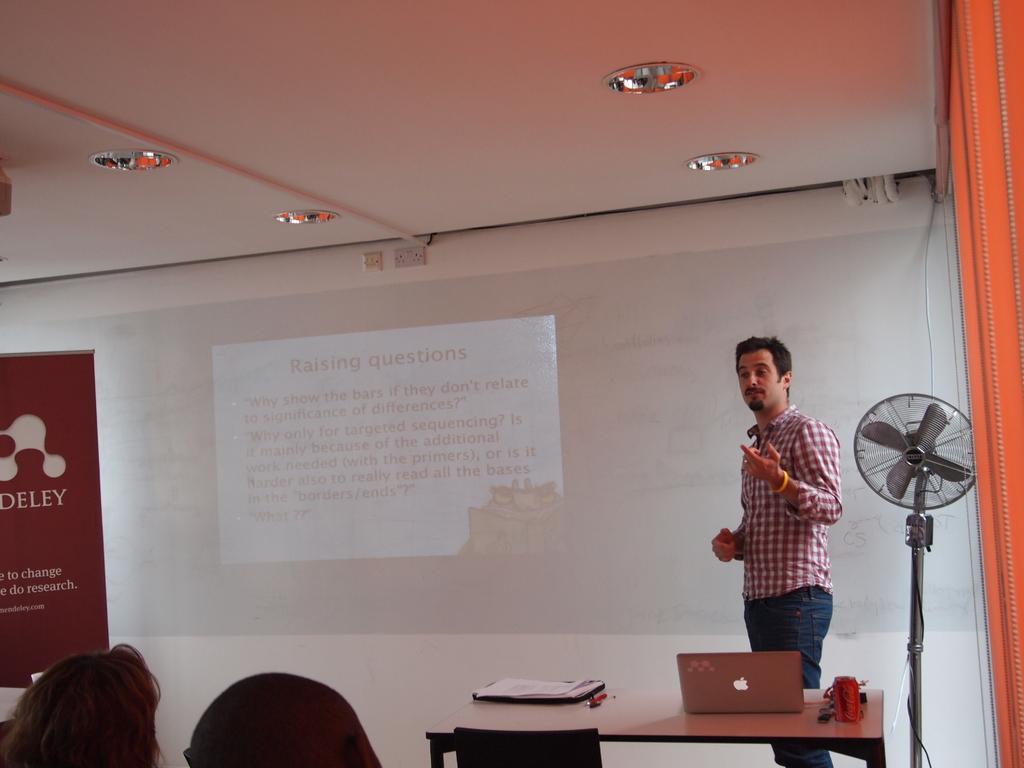How would you summarize this image in a sentence or two? Here we can able to see a screen on wall. In-front of this screen there is a banner. This man is standing. In-front of this man there is a table, on a table there is a laptop, pen and papers. Beside this man there is a fan. 